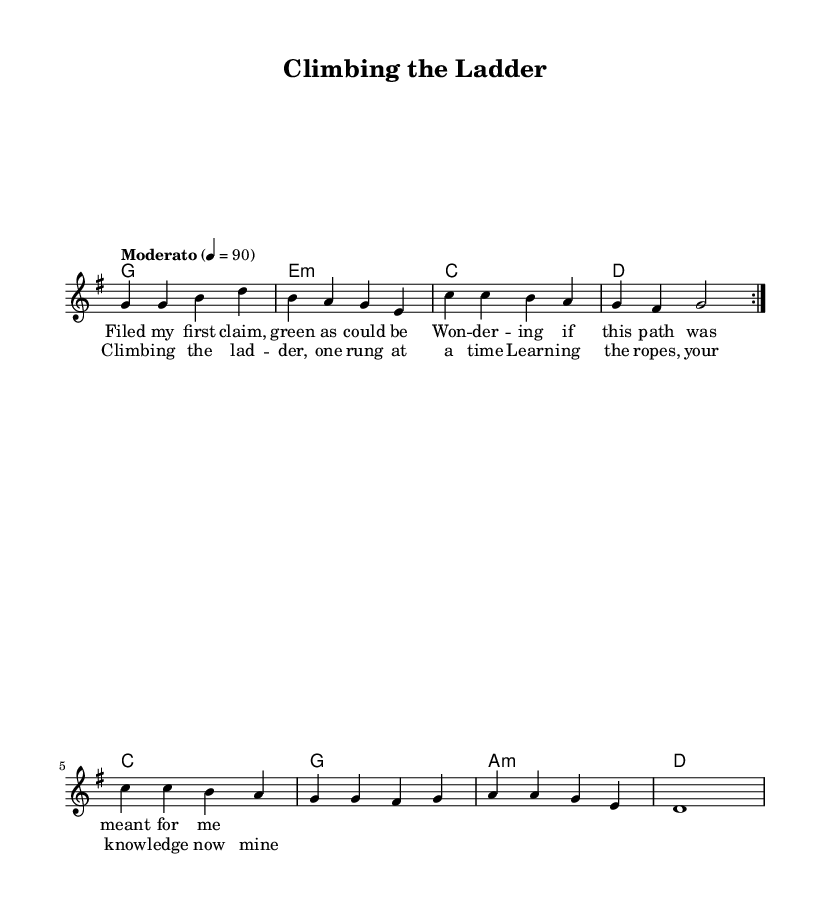What is the key signature of this music? The key signature is G major, which has one sharp (F#). This can be determined from the key signature indicated at the beginning of the score.
Answer: G major What is the time signature of this piece? The time signature is 4/4, which can be found at the beginning of the score where it is indicated by the numbers at the start of the staff.
Answer: 4/4 What is the tempo marking for this piece? The tempo marking states "Moderato" with a tempo of 90 beats per minute, indicated in the score right above the staff.
Answer: Moderato, 90 How many measures are repeated in the melody section? The melody section contains 2 measures that repeat twice, as indicated by the "repeat volta 2" marking at the beginning of that section.
Answer: 2 What chord accompanies the first measure of the verse? The chord in the first measure of the verse is G major, which matches the first chord indicated in the harmonies section.
Answer: G What is the last lyric of the chorus? The last lyric of the chorus is "now mine," as indicated at the end of the chorus lyrics section displayed in the score.
Answer: now mine How does the melody end, based on the sheet music? The melody ends on D, indicated by the final note of the melody line which is a half note, showing that the melody resolves on this note.
Answer: D 